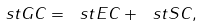Convert formula to latex. <formula><loc_0><loc_0><loc_500><loc_500>\ s t G C = \ s t E C + \ s t S C ,</formula> 